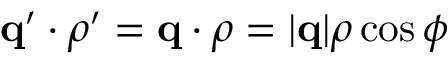Convert formula to latex. <formula><loc_0><loc_0><loc_500><loc_500>q ^ { \prime } \cdot \rho ^ { \prime } = q \cdot \rho = | q | \rho \cos \phi</formula> 